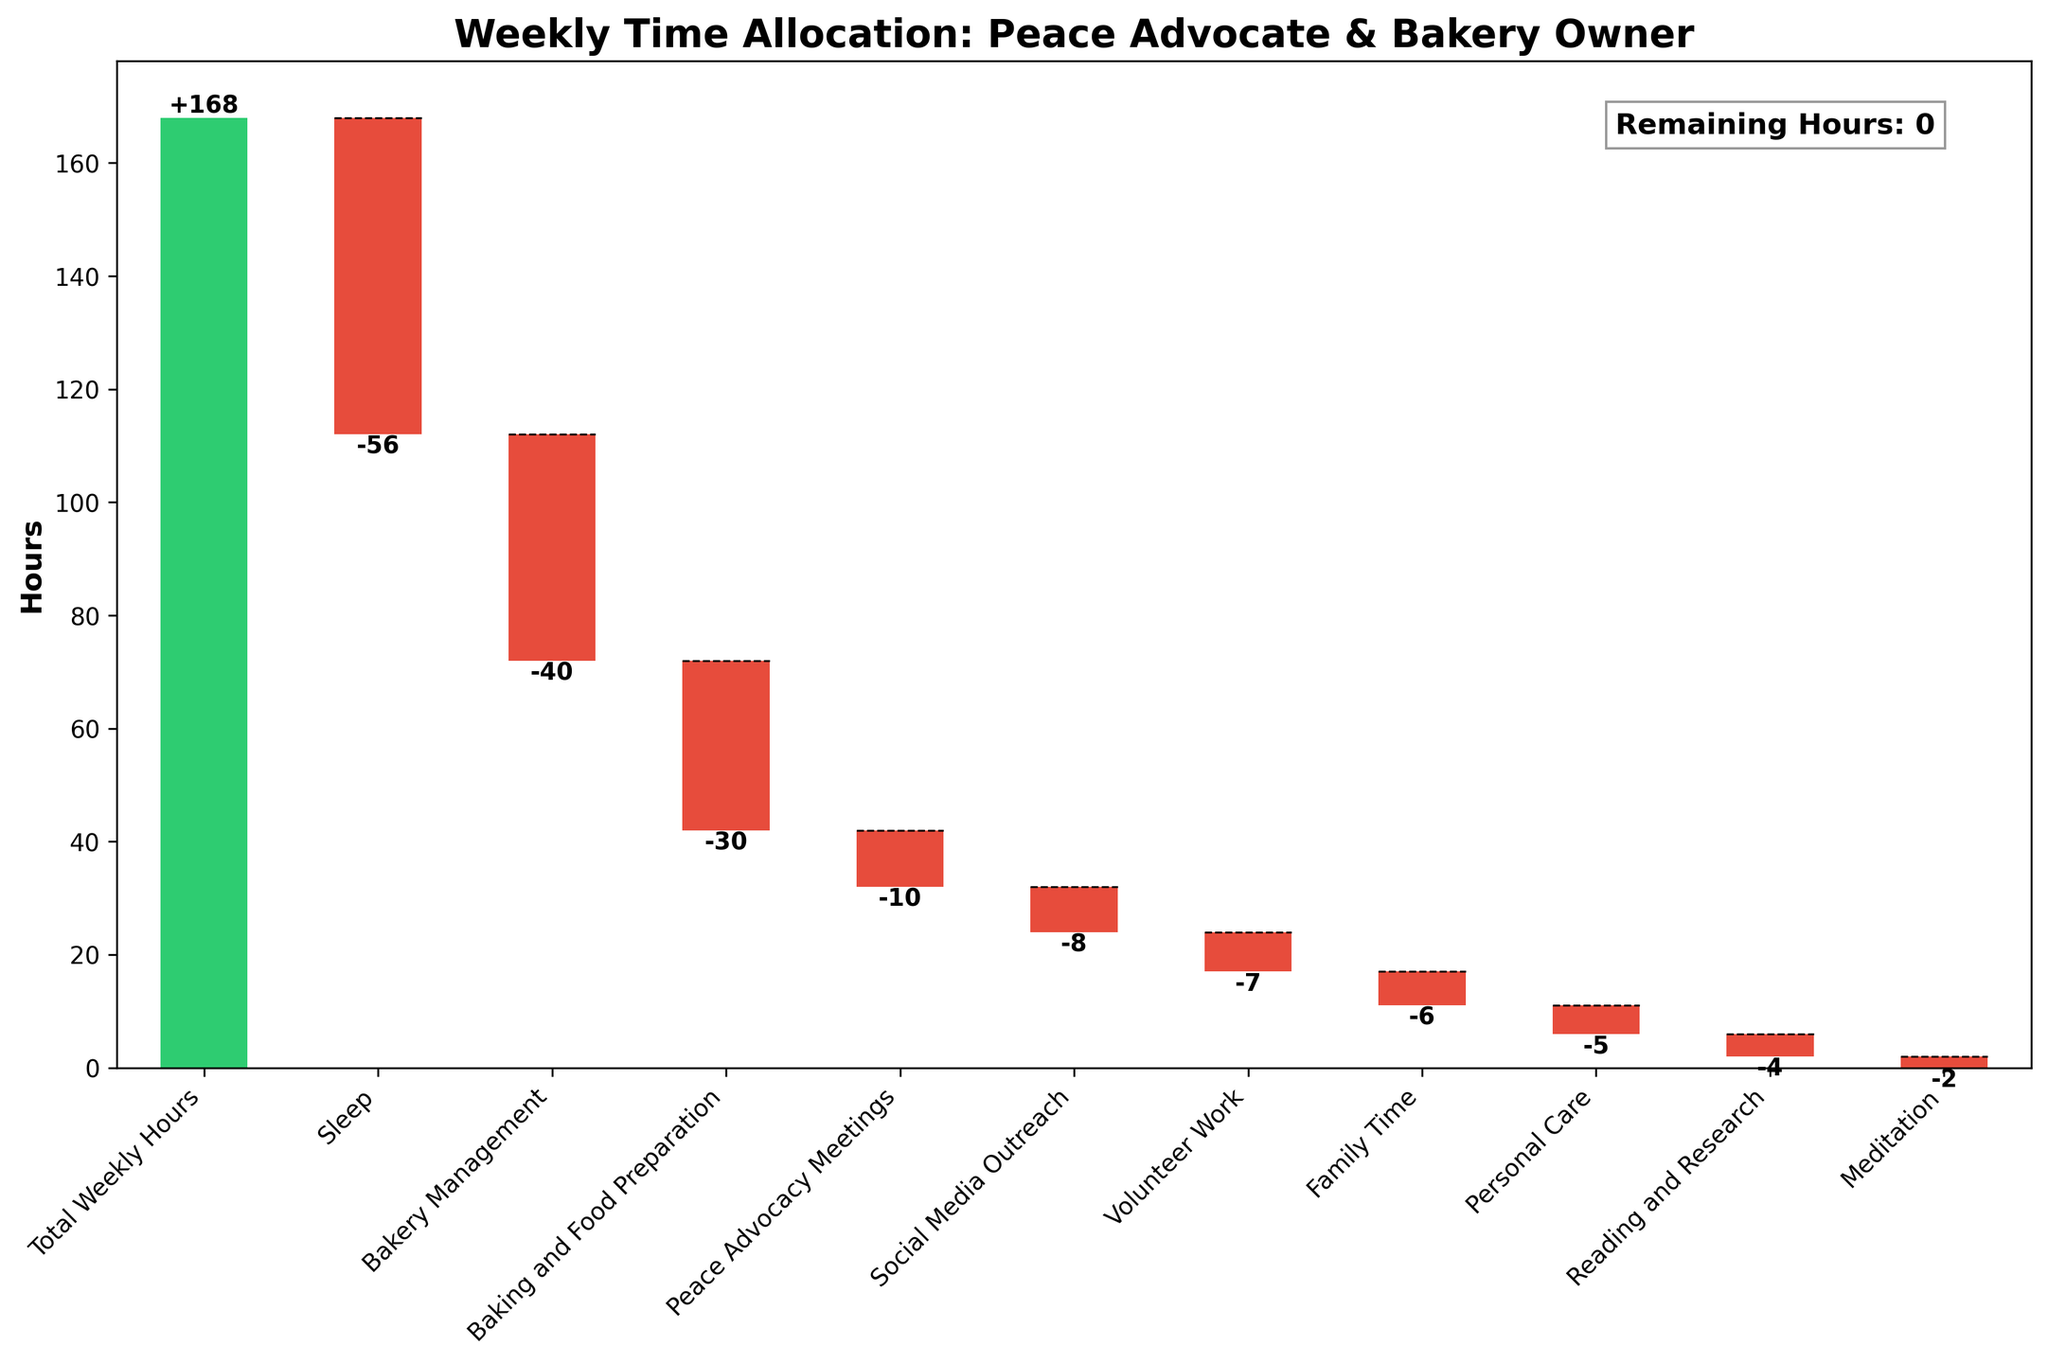What's the title of the chart? The title is typically placed at the top of the chart's axis. Here it reads "Weekly Time Allocation: Peace Advocate & Bakery Owner".
Answer: Weekly Time Allocation: Peace Advocate & Bakery Owner How many hours in total are considered for the week? At the top of the bars, the initial value given is the total weekly hours because it's the sum against which deductions are made. This figure is 168 hours.
Answer: 168 hours Which activity consumes the most hours per week? The activity with the largest negative bar represents the activity consuming the most hours. "Sleep" consumes -56 hours per week.
Answer: Sleep How many hours are spent on baking and food preparation? By identifying the baking and food preparation category on the x-axis, we see it corresponds to a -30 value.
Answer: 30 hours What is the total time spent on all peace advocacy-related activities (Peace Advocacy Meetings, Social Media Outreach, Volunteer Work)? Summing the hours of Peace Advocacy Meetings (-10), Social Media Outreach (-8), and Volunteer Work (-7), the total is -10 - 8 - 7 which equals -25 hours.
Answer: 25 hours What percentage of the week is spent on sleep? Since a week has 168 hours, and sleep takes 56 hours: (56/168) x 100 = 33.33%.
Answer: 33.33% Among the listed activities, which one is allocated the least time per week? The activity with the smallest negative value is "Meditation" with -2 hours per week.
Answer: Meditation How many hours are left unallocated after considering all the activities? The remaining hours are given in the text box in the chart, which calculates remaining hours after all subtractions: Remaining Hours: 0 hours.
Answer: 0 hours 